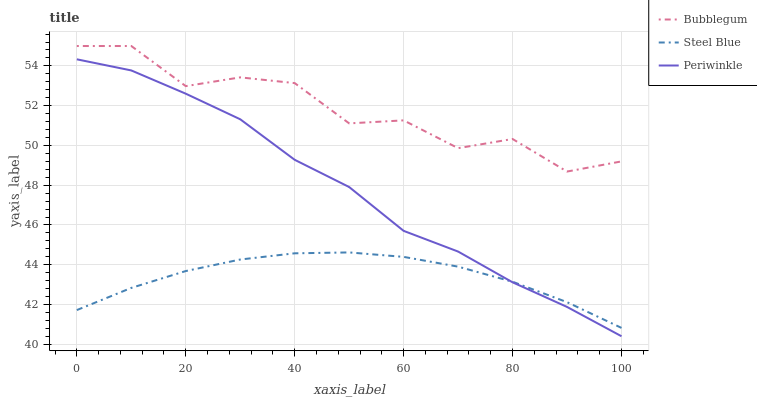Does Steel Blue have the minimum area under the curve?
Answer yes or no. Yes. Does Bubblegum have the maximum area under the curve?
Answer yes or no. Yes. Does Bubblegum have the minimum area under the curve?
Answer yes or no. No. Does Steel Blue have the maximum area under the curve?
Answer yes or no. No. Is Steel Blue the smoothest?
Answer yes or no. Yes. Is Bubblegum the roughest?
Answer yes or no. Yes. Is Bubblegum the smoothest?
Answer yes or no. No. Is Steel Blue the roughest?
Answer yes or no. No. Does Periwinkle have the lowest value?
Answer yes or no. Yes. Does Steel Blue have the lowest value?
Answer yes or no. No. Does Bubblegum have the highest value?
Answer yes or no. Yes. Does Steel Blue have the highest value?
Answer yes or no. No. Is Periwinkle less than Bubblegum?
Answer yes or no. Yes. Is Bubblegum greater than Steel Blue?
Answer yes or no. Yes. Does Periwinkle intersect Steel Blue?
Answer yes or no. Yes. Is Periwinkle less than Steel Blue?
Answer yes or no. No. Is Periwinkle greater than Steel Blue?
Answer yes or no. No. Does Periwinkle intersect Bubblegum?
Answer yes or no. No. 